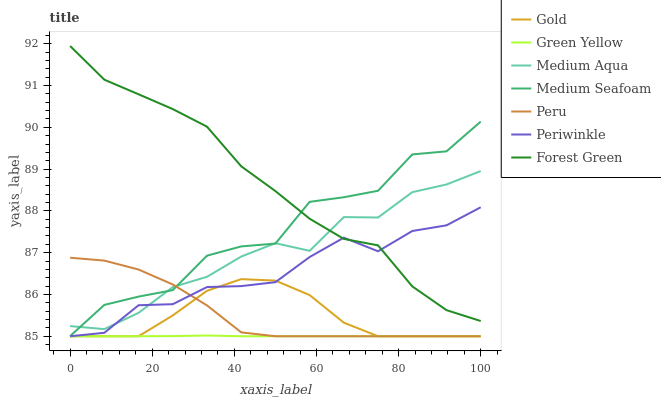Does Green Yellow have the minimum area under the curve?
Answer yes or no. Yes. Does Forest Green have the maximum area under the curve?
Answer yes or no. Yes. Does Periwinkle have the minimum area under the curve?
Answer yes or no. No. Does Periwinkle have the maximum area under the curve?
Answer yes or no. No. Is Green Yellow the smoothest?
Answer yes or no. Yes. Is Medium Seafoam the roughest?
Answer yes or no. Yes. Is Forest Green the smoothest?
Answer yes or no. No. Is Forest Green the roughest?
Answer yes or no. No. Does Gold have the lowest value?
Answer yes or no. Yes. Does Forest Green have the lowest value?
Answer yes or no. No. Does Forest Green have the highest value?
Answer yes or no. Yes. Does Periwinkle have the highest value?
Answer yes or no. No. Is Green Yellow less than Forest Green?
Answer yes or no. Yes. Is Medium Seafoam greater than Green Yellow?
Answer yes or no. Yes. Does Peru intersect Periwinkle?
Answer yes or no. Yes. Is Peru less than Periwinkle?
Answer yes or no. No. Is Peru greater than Periwinkle?
Answer yes or no. No. Does Green Yellow intersect Forest Green?
Answer yes or no. No. 